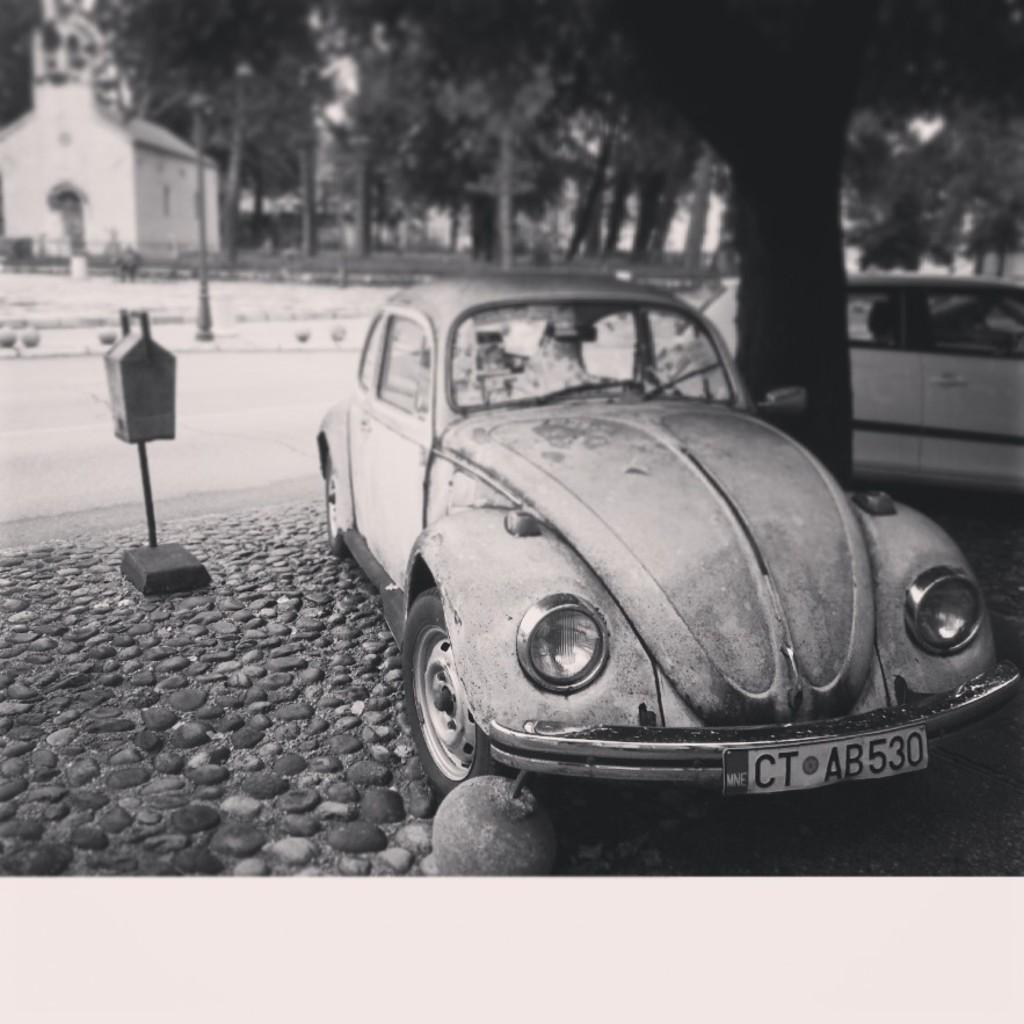What type of structure is visible in the image? There is a house in the image. What natural elements can be seen in the image? There are trees and rocks in the image. How many cars are present in the image? There are two cars in the image. What is the box attached to in the image? The box is attached to a stand in the image. What other object can be seen in the image? There is a pole in the image. What is the color scheme of the image? The image is in black and white mode. What type of lamp is present in the image? There is no lamp present in the image. What color is the gold object in the image? There is no gold object present in the image. 